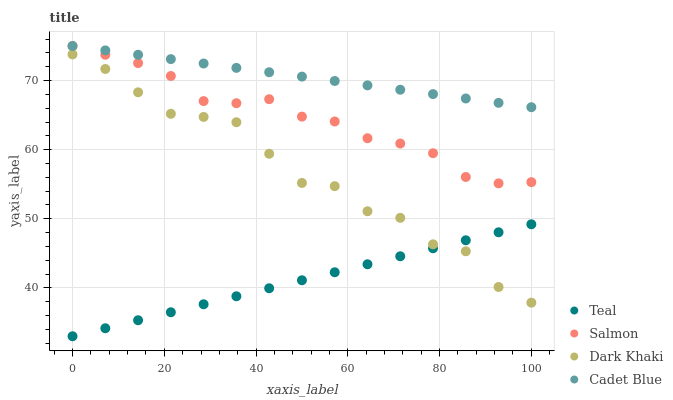Does Teal have the minimum area under the curve?
Answer yes or no. Yes. Does Cadet Blue have the maximum area under the curve?
Answer yes or no. Yes. Does Salmon have the minimum area under the curve?
Answer yes or no. No. Does Salmon have the maximum area under the curve?
Answer yes or no. No. Is Teal the smoothest?
Answer yes or no. Yes. Is Dark Khaki the roughest?
Answer yes or no. Yes. Is Cadet Blue the smoothest?
Answer yes or no. No. Is Cadet Blue the roughest?
Answer yes or no. No. Does Teal have the lowest value?
Answer yes or no. Yes. Does Salmon have the lowest value?
Answer yes or no. No. Does Salmon have the highest value?
Answer yes or no. Yes. Does Teal have the highest value?
Answer yes or no. No. Is Dark Khaki less than Cadet Blue?
Answer yes or no. Yes. Is Cadet Blue greater than Teal?
Answer yes or no. Yes. Does Salmon intersect Cadet Blue?
Answer yes or no. Yes. Is Salmon less than Cadet Blue?
Answer yes or no. No. Is Salmon greater than Cadet Blue?
Answer yes or no. No. Does Dark Khaki intersect Cadet Blue?
Answer yes or no. No. 